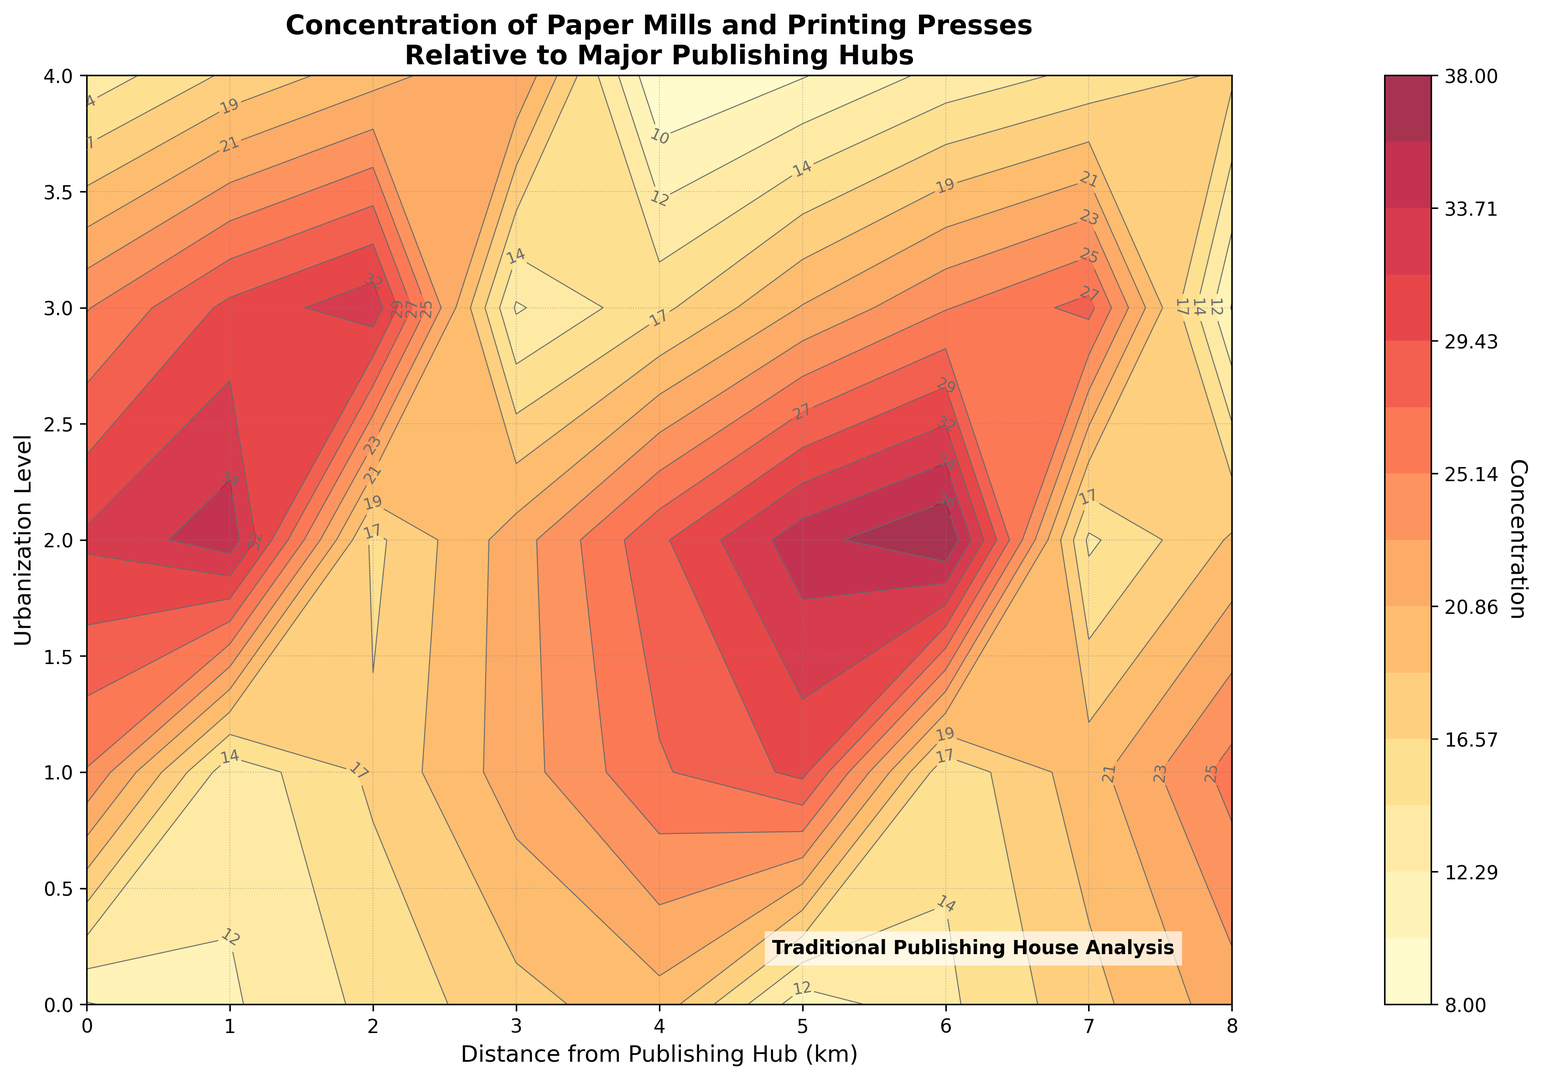Which area has the highest concentration of paper mills and printing presses? By scanning the contour plot, we identify that the highest concentration occurs at the coordinates where the darkest shades appear, which is at (4, 4).
Answer: (4, 4) How does the concentration change as you move from (0, 0) to (8, 0)? Starting from (0, 0) with a concentration of 10, moving through each point to (8, 0), the values are 10, 11, 13, 15, 16, 14, 12, 10, 8, which shows a decreasing trend overall.
Answer: Decreases Compare the concentration at (2, 2) with the concentration at (5, 2). Look at the contour values at these coordinates: the concentration at (2, 2) is 22, and at (5, 2) it is 25.
Answer: 22 at (2, 2) and 25 at (5, 2) What range of concentrations is depicted in the plot? The concentrations range from the lowest value in the data, 8, to the highest value, 38.
Answer: 8 to 38 What is the average concentration value along the y-axis at x = 0? The concentrations along the y-axis at x = 0 are 10, 12, 15, 18, 20. The average is calculated as (10 + 12 + 15 + 18 + 20) / 5 = 15.
Answer: 15 Are there areas with equal concentrations on the plot? If so, where? Reviewing the contour lines, which denote equal concentrations, we notice that at different coordinates across levels, such as (2, 4) and (3, 3), the concentration line intersects at 30.
Answer: Yes, for example at (2, 4) and (3, 3) How is the concentration distributed around the center of the plot at (4, 2)? The concentration at (4, 2) is 29, and looking around, it is higher than the surrounding points (3, 2) with 26 and (4, 1) with 22, but lower than (4, 3) with 35.
Answer: Higher than most surrounding points What patterns can be observed in terms of urbanization level in relation to concentration? As the urbanization level increases (higher y-values), the concentrations generally increase, indicating that higher urbanization levels are correlated with higher concentrations of paper mills and printing presses.
Answer: Positive correlation What is the concentration at (6, 3)? How does it compare to (6, 0)? The concentration at (6, 3) is 25, while at (6, 0) it is 12, indicating that (6, 3) has more than twice the concentration of (6, 0).
Answer: 25 at (6, 3) which is higher than 12 at (6, 0) What areas correspond to the lowest concentration values? The contour plot highlights that the lowest concentrations, shown by the lightest colors, are predominantly at the edges, particularly at (8, 0) with a concentration of 8.
Answer: Edge areas (*e.g., (8, 0) at 8*) 